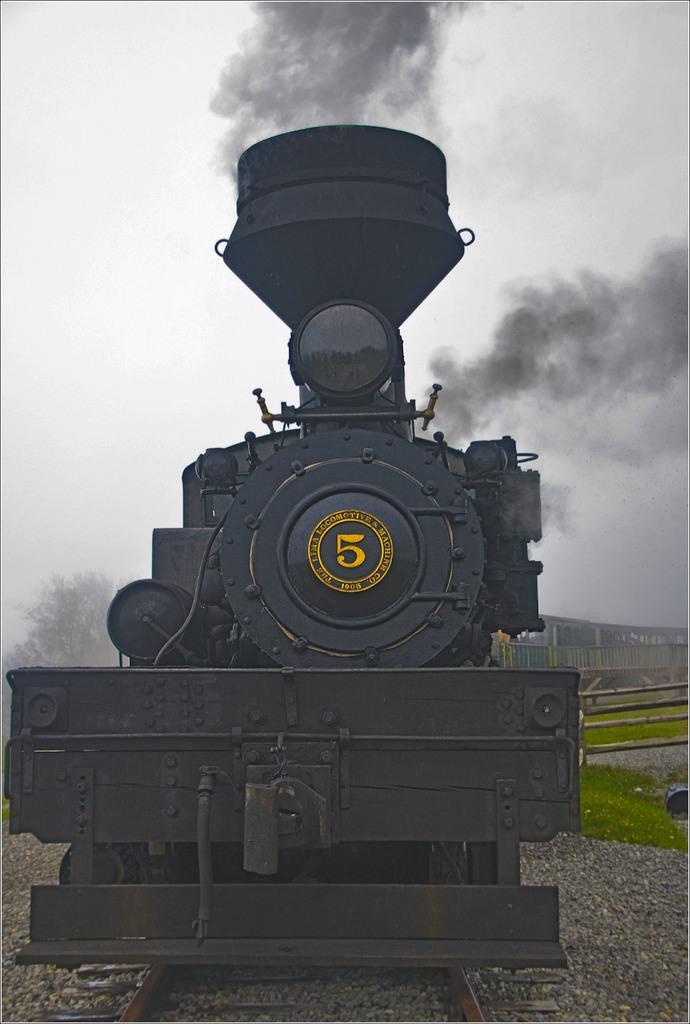Could you give a brief overview of what you see in this image? In the foreground of this image, there is a train moving on the track. On the right, there is the grass and small stones. On the left, there is a tree and the sky. On the top, there is the smoke. 